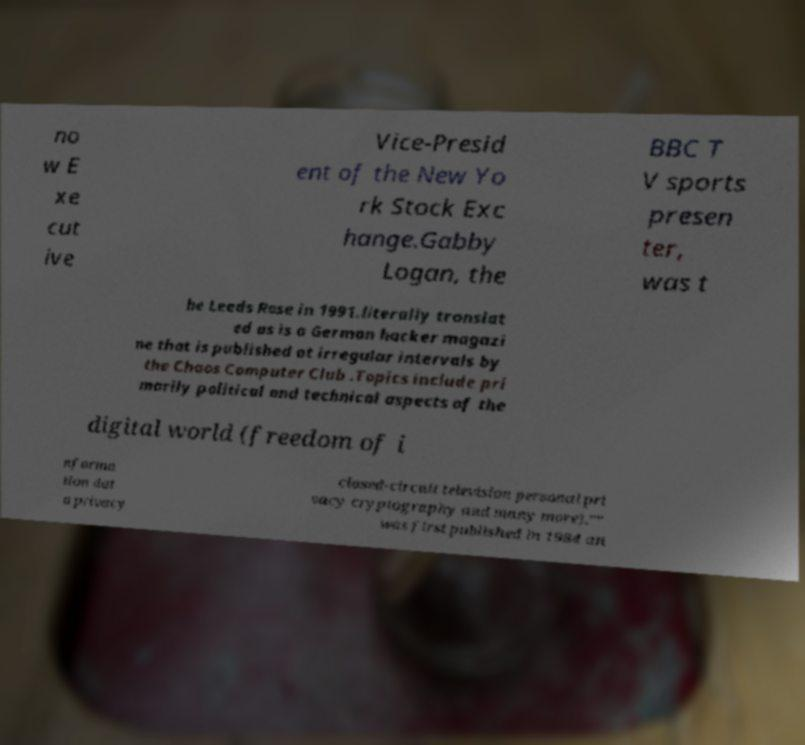Can you accurately transcribe the text from the provided image for me? no w E xe cut ive Vice-Presid ent of the New Yo rk Stock Exc hange.Gabby Logan, the BBC T V sports presen ter, was t he Leeds Rose in 1991.literally translat ed as is a German hacker magazi ne that is published at irregular intervals by the Chaos Computer Club .Topics include pri marily political and technical aspects of the digital world (freedom of i nforma tion dat a privacy closed-circuit television personal pri vacy cryptography and many more)."" was first published in 1984 an 